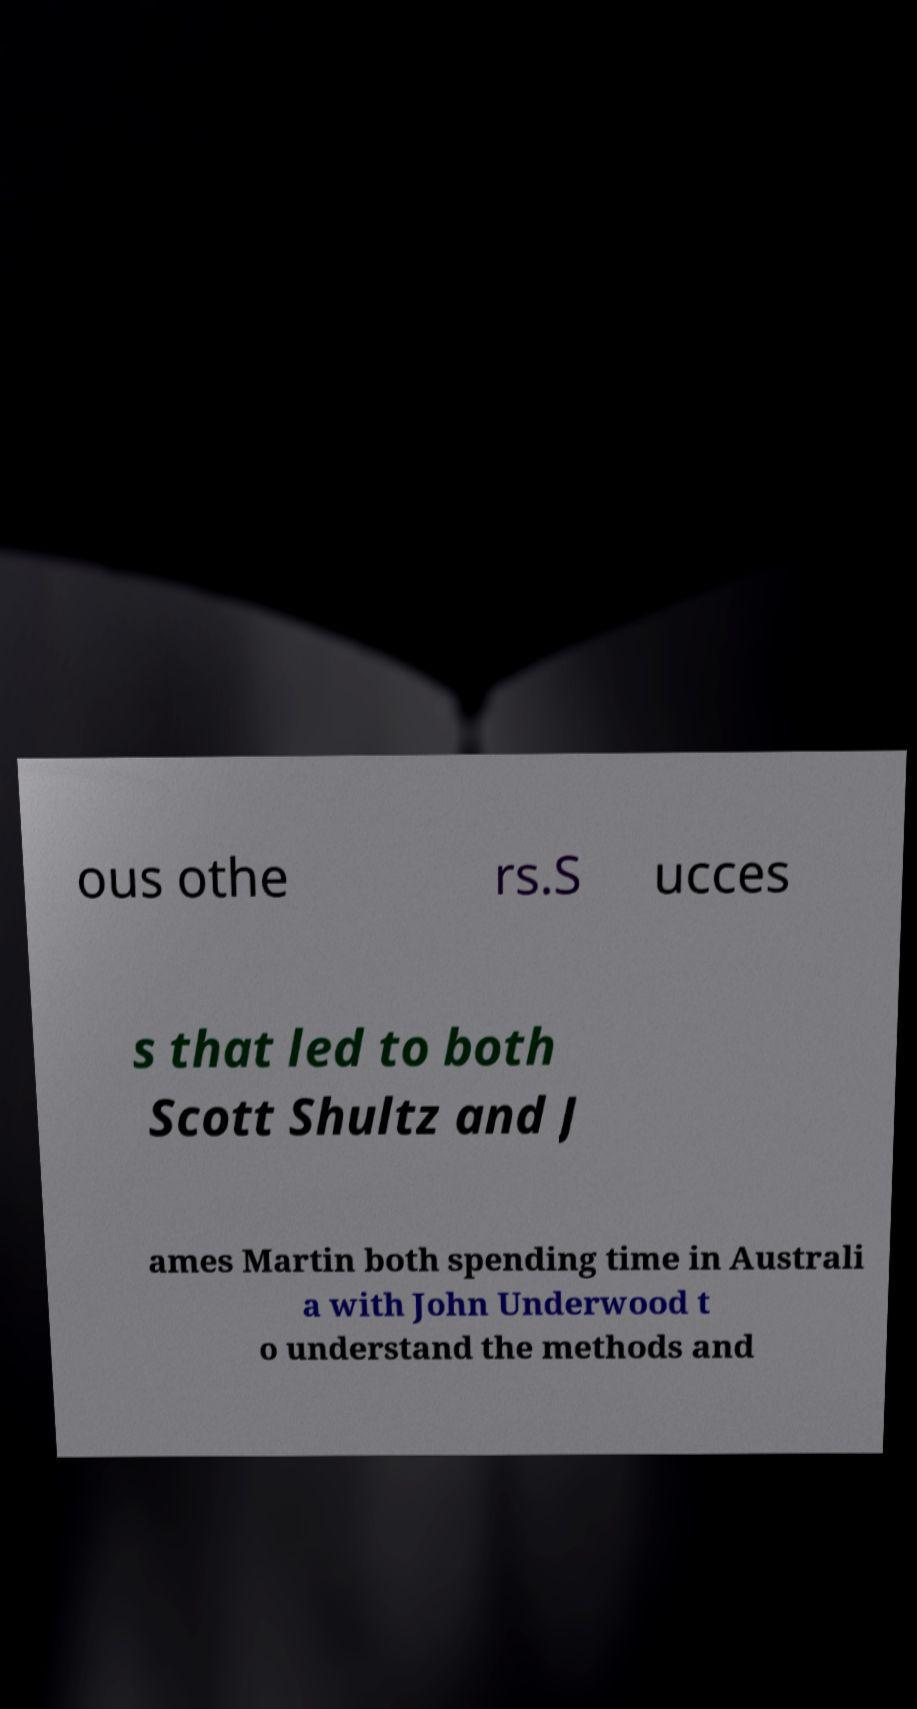Could you extract and type out the text from this image? ous othe rs.S ucces s that led to both Scott Shultz and J ames Martin both spending time in Australi a with John Underwood t o understand the methods and 